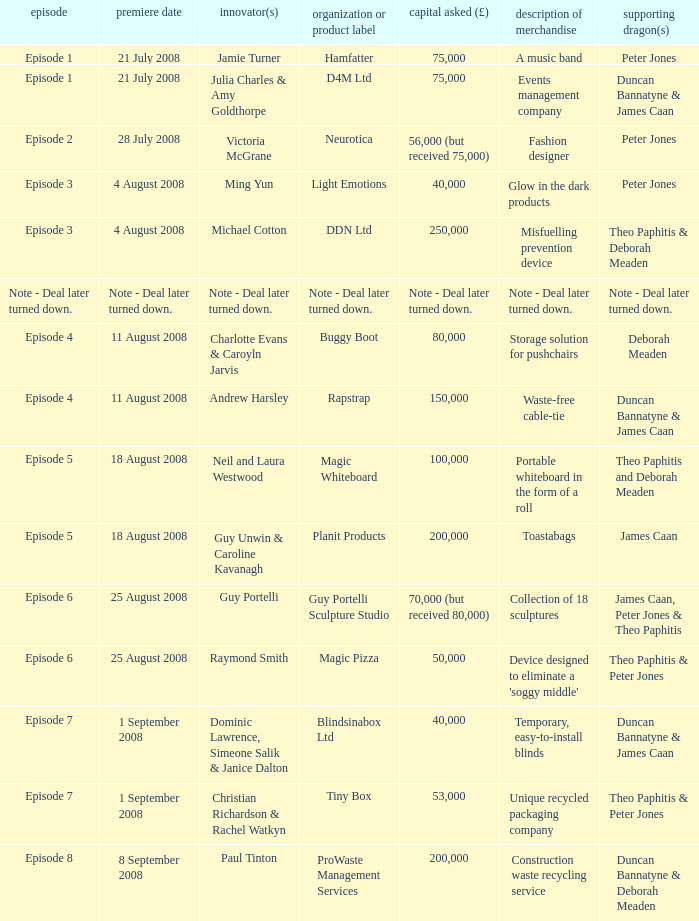Could you help me parse every detail presented in this table? {'header': ['episode', 'premiere date', 'innovator(s)', 'organization or product label', 'capital asked (£)', 'description of merchandise', 'supporting dragon(s)'], 'rows': [['Episode 1', '21 July 2008', 'Jamie Turner', 'Hamfatter', '75,000', 'A music band', 'Peter Jones'], ['Episode 1', '21 July 2008', 'Julia Charles & Amy Goldthorpe', 'D4M Ltd', '75,000', 'Events management company', 'Duncan Bannatyne & James Caan'], ['Episode 2', '28 July 2008', 'Victoria McGrane', 'Neurotica', '56,000 (but received 75,000)', 'Fashion designer', 'Peter Jones'], ['Episode 3', '4 August 2008', 'Ming Yun', 'Light Emotions', '40,000', 'Glow in the dark products', 'Peter Jones'], ['Episode 3', '4 August 2008', 'Michael Cotton', 'DDN Ltd', '250,000', 'Misfuelling prevention device', 'Theo Paphitis & Deborah Meaden'], ['Note - Deal later turned down.', 'Note - Deal later turned down.', 'Note - Deal later turned down.', 'Note - Deal later turned down.', 'Note - Deal later turned down.', 'Note - Deal later turned down.', 'Note - Deal later turned down.'], ['Episode 4', '11 August 2008', 'Charlotte Evans & Caroyln Jarvis', 'Buggy Boot', '80,000', 'Storage solution for pushchairs', 'Deborah Meaden'], ['Episode 4', '11 August 2008', 'Andrew Harsley', 'Rapstrap', '150,000', 'Waste-free cable-tie', 'Duncan Bannatyne & James Caan'], ['Episode 5', '18 August 2008', 'Neil and Laura Westwood', 'Magic Whiteboard', '100,000', 'Portable whiteboard in the form of a roll', 'Theo Paphitis and Deborah Meaden'], ['Episode 5', '18 August 2008', 'Guy Unwin & Caroline Kavanagh', 'Planit Products', '200,000', 'Toastabags', 'James Caan'], ['Episode 6', '25 August 2008', 'Guy Portelli', 'Guy Portelli Sculpture Studio', '70,000 (but received 80,000)', 'Collection of 18 sculptures', 'James Caan, Peter Jones & Theo Paphitis'], ['Episode 6', '25 August 2008', 'Raymond Smith', 'Magic Pizza', '50,000', "Device designed to eliminate a 'soggy middle'", 'Theo Paphitis & Peter Jones'], ['Episode 7', '1 September 2008', 'Dominic Lawrence, Simeone Salik & Janice Dalton', 'Blindsinabox Ltd', '40,000', 'Temporary, easy-to-install blinds', 'Duncan Bannatyne & James Caan'], ['Episode 7', '1 September 2008', 'Christian Richardson & Rachel Watkyn', 'Tiny Box', '53,000', 'Unique recycled packaging company', 'Theo Paphitis & Peter Jones'], ['Episode 8', '8 September 2008', 'Paul Tinton', 'ProWaste Management Services', '200,000', 'Construction waste recycling service', 'Duncan Bannatyne & Deborah Meaden']]} Who is the company Investing Dragons, or tiny box? Theo Paphitis & Peter Jones. 